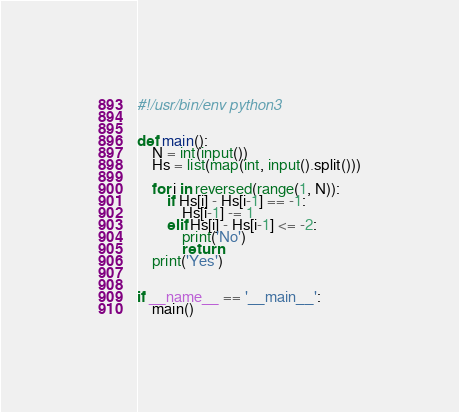<code> <loc_0><loc_0><loc_500><loc_500><_Python_>#!/usr/bin/env python3


def main():
    N = int(input())
    Hs = list(map(int, input().split()))

    for i in reversed(range(1, N)):
        if Hs[i] - Hs[i-1] == -1:
            Hs[i-1] -= 1
        elif Hs[i] - Hs[i-1] <= -2:
            print('No')
            return
    print('Yes')


if __name__ == '__main__':
    main()
</code> 